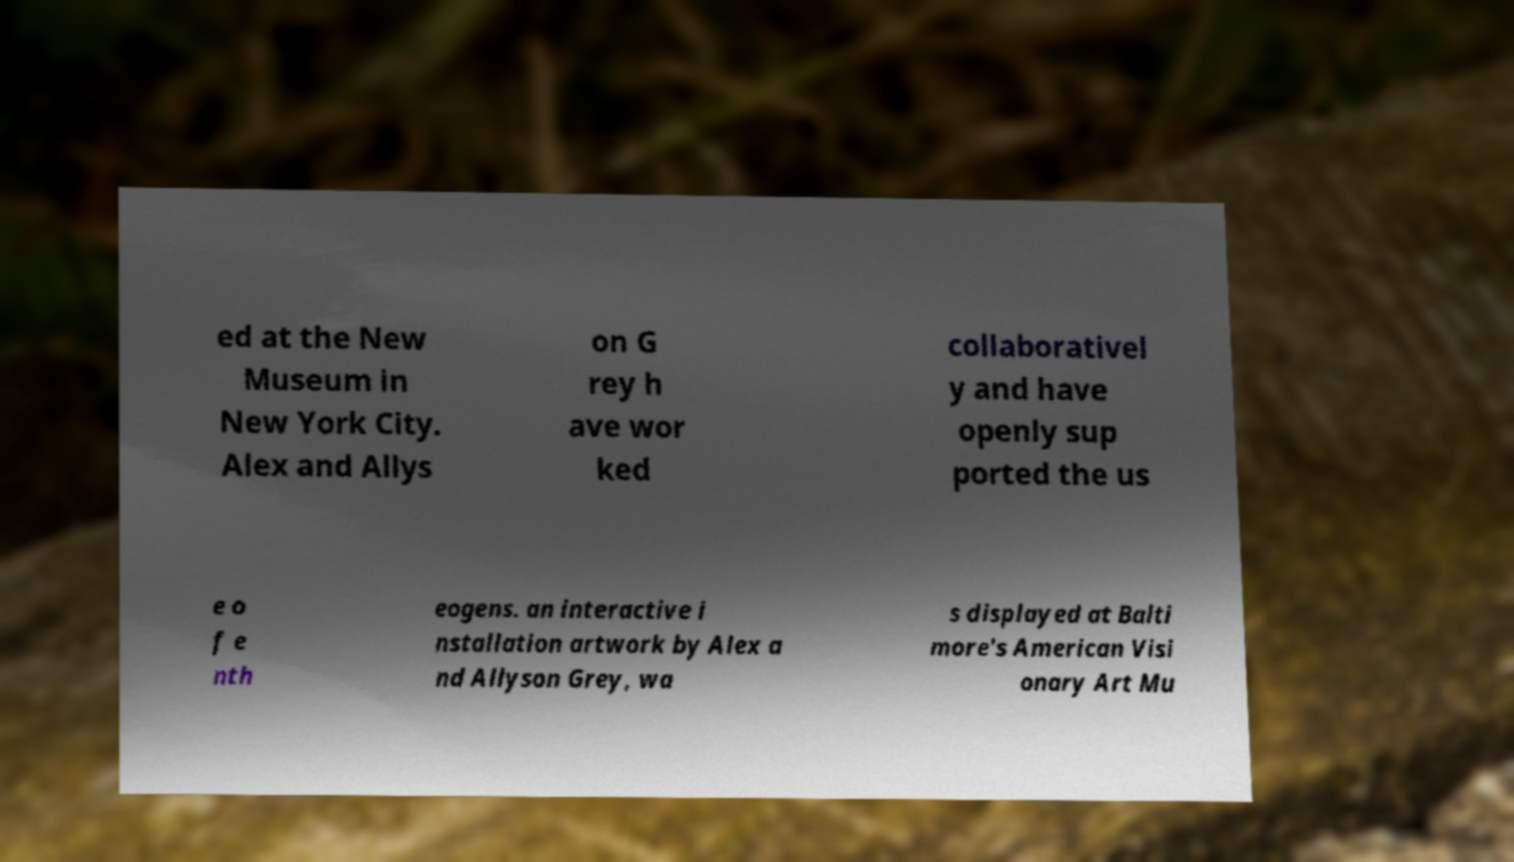Could you assist in decoding the text presented in this image and type it out clearly? ed at the New Museum in New York City. Alex and Allys on G rey h ave wor ked collaborativel y and have openly sup ported the us e o f e nth eogens. an interactive i nstallation artwork by Alex a nd Allyson Grey, wa s displayed at Balti more's American Visi onary Art Mu 